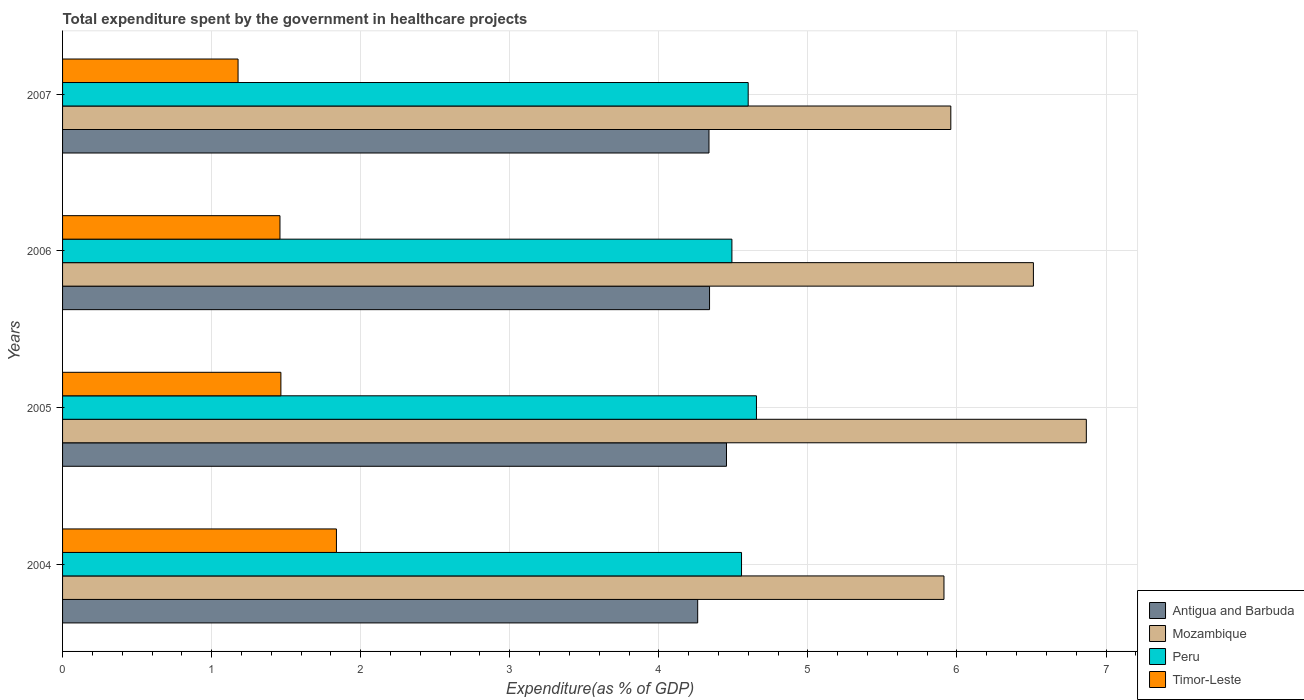How many groups of bars are there?
Offer a very short reply. 4. Are the number of bars on each tick of the Y-axis equal?
Your response must be concise. Yes. What is the label of the 4th group of bars from the top?
Keep it short and to the point. 2004. In how many cases, is the number of bars for a given year not equal to the number of legend labels?
Your answer should be very brief. 0. What is the total expenditure spent by the government in healthcare projects in Antigua and Barbuda in 2007?
Your answer should be very brief. 4.34. Across all years, what is the maximum total expenditure spent by the government in healthcare projects in Peru?
Your answer should be very brief. 4.65. Across all years, what is the minimum total expenditure spent by the government in healthcare projects in Timor-Leste?
Make the answer very short. 1.18. In which year was the total expenditure spent by the government in healthcare projects in Antigua and Barbuda maximum?
Your answer should be very brief. 2005. In which year was the total expenditure spent by the government in healthcare projects in Mozambique minimum?
Offer a terse response. 2004. What is the total total expenditure spent by the government in healthcare projects in Mozambique in the graph?
Your answer should be compact. 25.25. What is the difference between the total expenditure spent by the government in healthcare projects in Mozambique in 2004 and that in 2006?
Ensure brevity in your answer.  -0.6. What is the difference between the total expenditure spent by the government in healthcare projects in Antigua and Barbuda in 2006 and the total expenditure spent by the government in healthcare projects in Mozambique in 2005?
Give a very brief answer. -2.53. What is the average total expenditure spent by the government in healthcare projects in Peru per year?
Ensure brevity in your answer.  4.57. In the year 2004, what is the difference between the total expenditure spent by the government in healthcare projects in Timor-Leste and total expenditure spent by the government in healthcare projects in Peru?
Give a very brief answer. -2.72. What is the ratio of the total expenditure spent by the government in healthcare projects in Mozambique in 2006 to that in 2007?
Ensure brevity in your answer.  1.09. What is the difference between the highest and the second highest total expenditure spent by the government in healthcare projects in Mozambique?
Give a very brief answer. 0.36. What is the difference between the highest and the lowest total expenditure spent by the government in healthcare projects in Timor-Leste?
Your answer should be very brief. 0.66. Is it the case that in every year, the sum of the total expenditure spent by the government in healthcare projects in Peru and total expenditure spent by the government in healthcare projects in Mozambique is greater than the sum of total expenditure spent by the government in healthcare projects in Antigua and Barbuda and total expenditure spent by the government in healthcare projects in Timor-Leste?
Keep it short and to the point. Yes. What does the 3rd bar from the top in 2007 represents?
Keep it short and to the point. Mozambique. What does the 2nd bar from the bottom in 2006 represents?
Provide a succinct answer. Mozambique. Is it the case that in every year, the sum of the total expenditure spent by the government in healthcare projects in Peru and total expenditure spent by the government in healthcare projects in Antigua and Barbuda is greater than the total expenditure spent by the government in healthcare projects in Timor-Leste?
Provide a short and direct response. Yes. Are the values on the major ticks of X-axis written in scientific E-notation?
Give a very brief answer. No. Does the graph contain any zero values?
Offer a terse response. No. How many legend labels are there?
Offer a terse response. 4. What is the title of the graph?
Provide a succinct answer. Total expenditure spent by the government in healthcare projects. Does "Korea (Democratic)" appear as one of the legend labels in the graph?
Keep it short and to the point. No. What is the label or title of the X-axis?
Make the answer very short. Expenditure(as % of GDP). What is the label or title of the Y-axis?
Provide a succinct answer. Years. What is the Expenditure(as % of GDP) of Antigua and Barbuda in 2004?
Your response must be concise. 4.26. What is the Expenditure(as % of GDP) in Mozambique in 2004?
Provide a short and direct response. 5.91. What is the Expenditure(as % of GDP) of Peru in 2004?
Your answer should be very brief. 4.55. What is the Expenditure(as % of GDP) of Timor-Leste in 2004?
Offer a terse response. 1.84. What is the Expenditure(as % of GDP) in Antigua and Barbuda in 2005?
Provide a short and direct response. 4.45. What is the Expenditure(as % of GDP) of Mozambique in 2005?
Your answer should be very brief. 6.87. What is the Expenditure(as % of GDP) in Peru in 2005?
Your answer should be compact. 4.65. What is the Expenditure(as % of GDP) of Timor-Leste in 2005?
Your answer should be compact. 1.46. What is the Expenditure(as % of GDP) in Antigua and Barbuda in 2006?
Give a very brief answer. 4.34. What is the Expenditure(as % of GDP) in Mozambique in 2006?
Give a very brief answer. 6.51. What is the Expenditure(as % of GDP) of Peru in 2006?
Provide a succinct answer. 4.49. What is the Expenditure(as % of GDP) of Timor-Leste in 2006?
Your answer should be compact. 1.46. What is the Expenditure(as % of GDP) in Antigua and Barbuda in 2007?
Offer a terse response. 4.34. What is the Expenditure(as % of GDP) in Mozambique in 2007?
Ensure brevity in your answer.  5.96. What is the Expenditure(as % of GDP) in Peru in 2007?
Keep it short and to the point. 4.6. What is the Expenditure(as % of GDP) in Timor-Leste in 2007?
Make the answer very short. 1.18. Across all years, what is the maximum Expenditure(as % of GDP) in Antigua and Barbuda?
Provide a succinct answer. 4.45. Across all years, what is the maximum Expenditure(as % of GDP) in Mozambique?
Your response must be concise. 6.87. Across all years, what is the maximum Expenditure(as % of GDP) of Peru?
Keep it short and to the point. 4.65. Across all years, what is the maximum Expenditure(as % of GDP) in Timor-Leste?
Provide a short and direct response. 1.84. Across all years, what is the minimum Expenditure(as % of GDP) of Antigua and Barbuda?
Your response must be concise. 4.26. Across all years, what is the minimum Expenditure(as % of GDP) in Mozambique?
Your answer should be compact. 5.91. Across all years, what is the minimum Expenditure(as % of GDP) of Peru?
Provide a succinct answer. 4.49. Across all years, what is the minimum Expenditure(as % of GDP) in Timor-Leste?
Offer a very short reply. 1.18. What is the total Expenditure(as % of GDP) of Antigua and Barbuda in the graph?
Make the answer very short. 17.39. What is the total Expenditure(as % of GDP) of Mozambique in the graph?
Provide a succinct answer. 25.25. What is the total Expenditure(as % of GDP) of Peru in the graph?
Your response must be concise. 18.3. What is the total Expenditure(as % of GDP) of Timor-Leste in the graph?
Offer a very short reply. 5.94. What is the difference between the Expenditure(as % of GDP) of Antigua and Barbuda in 2004 and that in 2005?
Offer a terse response. -0.19. What is the difference between the Expenditure(as % of GDP) in Mozambique in 2004 and that in 2005?
Your answer should be very brief. -0.96. What is the difference between the Expenditure(as % of GDP) of Peru in 2004 and that in 2005?
Provide a short and direct response. -0.1. What is the difference between the Expenditure(as % of GDP) of Timor-Leste in 2004 and that in 2005?
Provide a short and direct response. 0.37. What is the difference between the Expenditure(as % of GDP) of Antigua and Barbuda in 2004 and that in 2006?
Make the answer very short. -0.08. What is the difference between the Expenditure(as % of GDP) of Mozambique in 2004 and that in 2006?
Offer a very short reply. -0.6. What is the difference between the Expenditure(as % of GDP) of Peru in 2004 and that in 2006?
Your answer should be very brief. 0.06. What is the difference between the Expenditure(as % of GDP) in Timor-Leste in 2004 and that in 2006?
Give a very brief answer. 0.38. What is the difference between the Expenditure(as % of GDP) in Antigua and Barbuda in 2004 and that in 2007?
Make the answer very short. -0.08. What is the difference between the Expenditure(as % of GDP) in Mozambique in 2004 and that in 2007?
Your response must be concise. -0.05. What is the difference between the Expenditure(as % of GDP) in Peru in 2004 and that in 2007?
Keep it short and to the point. -0.04. What is the difference between the Expenditure(as % of GDP) of Timor-Leste in 2004 and that in 2007?
Ensure brevity in your answer.  0.66. What is the difference between the Expenditure(as % of GDP) in Antigua and Barbuda in 2005 and that in 2006?
Provide a short and direct response. 0.11. What is the difference between the Expenditure(as % of GDP) of Mozambique in 2005 and that in 2006?
Keep it short and to the point. 0.35. What is the difference between the Expenditure(as % of GDP) in Peru in 2005 and that in 2006?
Offer a very short reply. 0.16. What is the difference between the Expenditure(as % of GDP) in Timor-Leste in 2005 and that in 2006?
Your answer should be compact. 0.01. What is the difference between the Expenditure(as % of GDP) of Antigua and Barbuda in 2005 and that in 2007?
Your answer should be very brief. 0.12. What is the difference between the Expenditure(as % of GDP) in Peru in 2005 and that in 2007?
Make the answer very short. 0.06. What is the difference between the Expenditure(as % of GDP) of Timor-Leste in 2005 and that in 2007?
Your answer should be very brief. 0.29. What is the difference between the Expenditure(as % of GDP) of Antigua and Barbuda in 2006 and that in 2007?
Your response must be concise. 0. What is the difference between the Expenditure(as % of GDP) of Mozambique in 2006 and that in 2007?
Offer a very short reply. 0.55. What is the difference between the Expenditure(as % of GDP) in Peru in 2006 and that in 2007?
Make the answer very short. -0.11. What is the difference between the Expenditure(as % of GDP) in Timor-Leste in 2006 and that in 2007?
Offer a terse response. 0.28. What is the difference between the Expenditure(as % of GDP) of Antigua and Barbuda in 2004 and the Expenditure(as % of GDP) of Mozambique in 2005?
Provide a short and direct response. -2.61. What is the difference between the Expenditure(as % of GDP) of Antigua and Barbuda in 2004 and the Expenditure(as % of GDP) of Peru in 2005?
Provide a short and direct response. -0.39. What is the difference between the Expenditure(as % of GDP) of Antigua and Barbuda in 2004 and the Expenditure(as % of GDP) of Timor-Leste in 2005?
Your response must be concise. 2.8. What is the difference between the Expenditure(as % of GDP) in Mozambique in 2004 and the Expenditure(as % of GDP) in Peru in 2005?
Ensure brevity in your answer.  1.26. What is the difference between the Expenditure(as % of GDP) of Mozambique in 2004 and the Expenditure(as % of GDP) of Timor-Leste in 2005?
Give a very brief answer. 4.45. What is the difference between the Expenditure(as % of GDP) in Peru in 2004 and the Expenditure(as % of GDP) in Timor-Leste in 2005?
Offer a terse response. 3.09. What is the difference between the Expenditure(as % of GDP) in Antigua and Barbuda in 2004 and the Expenditure(as % of GDP) in Mozambique in 2006?
Keep it short and to the point. -2.25. What is the difference between the Expenditure(as % of GDP) in Antigua and Barbuda in 2004 and the Expenditure(as % of GDP) in Peru in 2006?
Your answer should be compact. -0.23. What is the difference between the Expenditure(as % of GDP) of Antigua and Barbuda in 2004 and the Expenditure(as % of GDP) of Timor-Leste in 2006?
Your response must be concise. 2.8. What is the difference between the Expenditure(as % of GDP) in Mozambique in 2004 and the Expenditure(as % of GDP) in Peru in 2006?
Give a very brief answer. 1.42. What is the difference between the Expenditure(as % of GDP) of Mozambique in 2004 and the Expenditure(as % of GDP) of Timor-Leste in 2006?
Provide a short and direct response. 4.45. What is the difference between the Expenditure(as % of GDP) in Peru in 2004 and the Expenditure(as % of GDP) in Timor-Leste in 2006?
Keep it short and to the point. 3.1. What is the difference between the Expenditure(as % of GDP) of Antigua and Barbuda in 2004 and the Expenditure(as % of GDP) of Mozambique in 2007?
Provide a short and direct response. -1.7. What is the difference between the Expenditure(as % of GDP) of Antigua and Barbuda in 2004 and the Expenditure(as % of GDP) of Peru in 2007?
Keep it short and to the point. -0.34. What is the difference between the Expenditure(as % of GDP) in Antigua and Barbuda in 2004 and the Expenditure(as % of GDP) in Timor-Leste in 2007?
Make the answer very short. 3.08. What is the difference between the Expenditure(as % of GDP) of Mozambique in 2004 and the Expenditure(as % of GDP) of Peru in 2007?
Offer a terse response. 1.31. What is the difference between the Expenditure(as % of GDP) of Mozambique in 2004 and the Expenditure(as % of GDP) of Timor-Leste in 2007?
Provide a succinct answer. 4.74. What is the difference between the Expenditure(as % of GDP) in Peru in 2004 and the Expenditure(as % of GDP) in Timor-Leste in 2007?
Provide a succinct answer. 3.38. What is the difference between the Expenditure(as % of GDP) in Antigua and Barbuda in 2005 and the Expenditure(as % of GDP) in Mozambique in 2006?
Your answer should be very brief. -2.06. What is the difference between the Expenditure(as % of GDP) in Antigua and Barbuda in 2005 and the Expenditure(as % of GDP) in Peru in 2006?
Ensure brevity in your answer.  -0.04. What is the difference between the Expenditure(as % of GDP) of Antigua and Barbuda in 2005 and the Expenditure(as % of GDP) of Timor-Leste in 2006?
Ensure brevity in your answer.  3. What is the difference between the Expenditure(as % of GDP) in Mozambique in 2005 and the Expenditure(as % of GDP) in Peru in 2006?
Your answer should be very brief. 2.38. What is the difference between the Expenditure(as % of GDP) in Mozambique in 2005 and the Expenditure(as % of GDP) in Timor-Leste in 2006?
Provide a short and direct response. 5.41. What is the difference between the Expenditure(as % of GDP) of Peru in 2005 and the Expenditure(as % of GDP) of Timor-Leste in 2006?
Ensure brevity in your answer.  3.2. What is the difference between the Expenditure(as % of GDP) of Antigua and Barbuda in 2005 and the Expenditure(as % of GDP) of Mozambique in 2007?
Your response must be concise. -1.5. What is the difference between the Expenditure(as % of GDP) of Antigua and Barbuda in 2005 and the Expenditure(as % of GDP) of Peru in 2007?
Provide a succinct answer. -0.15. What is the difference between the Expenditure(as % of GDP) in Antigua and Barbuda in 2005 and the Expenditure(as % of GDP) in Timor-Leste in 2007?
Give a very brief answer. 3.28. What is the difference between the Expenditure(as % of GDP) in Mozambique in 2005 and the Expenditure(as % of GDP) in Peru in 2007?
Make the answer very short. 2.27. What is the difference between the Expenditure(as % of GDP) in Mozambique in 2005 and the Expenditure(as % of GDP) in Timor-Leste in 2007?
Offer a very short reply. 5.69. What is the difference between the Expenditure(as % of GDP) in Peru in 2005 and the Expenditure(as % of GDP) in Timor-Leste in 2007?
Your answer should be compact. 3.48. What is the difference between the Expenditure(as % of GDP) of Antigua and Barbuda in 2006 and the Expenditure(as % of GDP) of Mozambique in 2007?
Your answer should be very brief. -1.62. What is the difference between the Expenditure(as % of GDP) in Antigua and Barbuda in 2006 and the Expenditure(as % of GDP) in Peru in 2007?
Keep it short and to the point. -0.26. What is the difference between the Expenditure(as % of GDP) in Antigua and Barbuda in 2006 and the Expenditure(as % of GDP) in Timor-Leste in 2007?
Provide a succinct answer. 3.16. What is the difference between the Expenditure(as % of GDP) in Mozambique in 2006 and the Expenditure(as % of GDP) in Peru in 2007?
Give a very brief answer. 1.91. What is the difference between the Expenditure(as % of GDP) in Mozambique in 2006 and the Expenditure(as % of GDP) in Timor-Leste in 2007?
Provide a short and direct response. 5.34. What is the difference between the Expenditure(as % of GDP) in Peru in 2006 and the Expenditure(as % of GDP) in Timor-Leste in 2007?
Your answer should be compact. 3.31. What is the average Expenditure(as % of GDP) of Antigua and Barbuda per year?
Your answer should be very brief. 4.35. What is the average Expenditure(as % of GDP) in Mozambique per year?
Offer a very short reply. 6.31. What is the average Expenditure(as % of GDP) in Peru per year?
Your answer should be very brief. 4.57. What is the average Expenditure(as % of GDP) of Timor-Leste per year?
Provide a short and direct response. 1.48. In the year 2004, what is the difference between the Expenditure(as % of GDP) in Antigua and Barbuda and Expenditure(as % of GDP) in Mozambique?
Offer a terse response. -1.65. In the year 2004, what is the difference between the Expenditure(as % of GDP) in Antigua and Barbuda and Expenditure(as % of GDP) in Peru?
Provide a short and direct response. -0.29. In the year 2004, what is the difference between the Expenditure(as % of GDP) in Antigua and Barbuda and Expenditure(as % of GDP) in Timor-Leste?
Your answer should be very brief. 2.42. In the year 2004, what is the difference between the Expenditure(as % of GDP) of Mozambique and Expenditure(as % of GDP) of Peru?
Ensure brevity in your answer.  1.36. In the year 2004, what is the difference between the Expenditure(as % of GDP) in Mozambique and Expenditure(as % of GDP) in Timor-Leste?
Your answer should be very brief. 4.08. In the year 2004, what is the difference between the Expenditure(as % of GDP) of Peru and Expenditure(as % of GDP) of Timor-Leste?
Ensure brevity in your answer.  2.72. In the year 2005, what is the difference between the Expenditure(as % of GDP) in Antigua and Barbuda and Expenditure(as % of GDP) in Mozambique?
Make the answer very short. -2.41. In the year 2005, what is the difference between the Expenditure(as % of GDP) in Antigua and Barbuda and Expenditure(as % of GDP) in Peru?
Provide a short and direct response. -0.2. In the year 2005, what is the difference between the Expenditure(as % of GDP) of Antigua and Barbuda and Expenditure(as % of GDP) of Timor-Leste?
Offer a very short reply. 2.99. In the year 2005, what is the difference between the Expenditure(as % of GDP) in Mozambique and Expenditure(as % of GDP) in Peru?
Your answer should be compact. 2.21. In the year 2005, what is the difference between the Expenditure(as % of GDP) in Mozambique and Expenditure(as % of GDP) in Timor-Leste?
Make the answer very short. 5.4. In the year 2005, what is the difference between the Expenditure(as % of GDP) of Peru and Expenditure(as % of GDP) of Timor-Leste?
Ensure brevity in your answer.  3.19. In the year 2006, what is the difference between the Expenditure(as % of GDP) of Antigua and Barbuda and Expenditure(as % of GDP) of Mozambique?
Give a very brief answer. -2.17. In the year 2006, what is the difference between the Expenditure(as % of GDP) of Antigua and Barbuda and Expenditure(as % of GDP) of Peru?
Offer a very short reply. -0.15. In the year 2006, what is the difference between the Expenditure(as % of GDP) of Antigua and Barbuda and Expenditure(as % of GDP) of Timor-Leste?
Offer a very short reply. 2.88. In the year 2006, what is the difference between the Expenditure(as % of GDP) in Mozambique and Expenditure(as % of GDP) in Peru?
Ensure brevity in your answer.  2.02. In the year 2006, what is the difference between the Expenditure(as % of GDP) of Mozambique and Expenditure(as % of GDP) of Timor-Leste?
Keep it short and to the point. 5.05. In the year 2006, what is the difference between the Expenditure(as % of GDP) of Peru and Expenditure(as % of GDP) of Timor-Leste?
Ensure brevity in your answer.  3.03. In the year 2007, what is the difference between the Expenditure(as % of GDP) of Antigua and Barbuda and Expenditure(as % of GDP) of Mozambique?
Give a very brief answer. -1.62. In the year 2007, what is the difference between the Expenditure(as % of GDP) in Antigua and Barbuda and Expenditure(as % of GDP) in Peru?
Offer a terse response. -0.26. In the year 2007, what is the difference between the Expenditure(as % of GDP) in Antigua and Barbuda and Expenditure(as % of GDP) in Timor-Leste?
Offer a very short reply. 3.16. In the year 2007, what is the difference between the Expenditure(as % of GDP) in Mozambique and Expenditure(as % of GDP) in Peru?
Offer a terse response. 1.36. In the year 2007, what is the difference between the Expenditure(as % of GDP) in Mozambique and Expenditure(as % of GDP) in Timor-Leste?
Offer a very short reply. 4.78. In the year 2007, what is the difference between the Expenditure(as % of GDP) in Peru and Expenditure(as % of GDP) in Timor-Leste?
Give a very brief answer. 3.42. What is the ratio of the Expenditure(as % of GDP) of Antigua and Barbuda in 2004 to that in 2005?
Ensure brevity in your answer.  0.96. What is the ratio of the Expenditure(as % of GDP) of Mozambique in 2004 to that in 2005?
Your answer should be very brief. 0.86. What is the ratio of the Expenditure(as % of GDP) of Peru in 2004 to that in 2005?
Provide a succinct answer. 0.98. What is the ratio of the Expenditure(as % of GDP) of Timor-Leste in 2004 to that in 2005?
Your answer should be compact. 1.25. What is the ratio of the Expenditure(as % of GDP) of Antigua and Barbuda in 2004 to that in 2006?
Give a very brief answer. 0.98. What is the ratio of the Expenditure(as % of GDP) in Mozambique in 2004 to that in 2006?
Your answer should be compact. 0.91. What is the ratio of the Expenditure(as % of GDP) of Peru in 2004 to that in 2006?
Your response must be concise. 1.01. What is the ratio of the Expenditure(as % of GDP) in Timor-Leste in 2004 to that in 2006?
Make the answer very short. 1.26. What is the ratio of the Expenditure(as % of GDP) of Antigua and Barbuda in 2004 to that in 2007?
Keep it short and to the point. 0.98. What is the ratio of the Expenditure(as % of GDP) of Mozambique in 2004 to that in 2007?
Your answer should be compact. 0.99. What is the ratio of the Expenditure(as % of GDP) of Peru in 2004 to that in 2007?
Your answer should be very brief. 0.99. What is the ratio of the Expenditure(as % of GDP) of Timor-Leste in 2004 to that in 2007?
Your answer should be very brief. 1.56. What is the ratio of the Expenditure(as % of GDP) in Antigua and Barbuda in 2005 to that in 2006?
Provide a short and direct response. 1.03. What is the ratio of the Expenditure(as % of GDP) in Mozambique in 2005 to that in 2006?
Offer a terse response. 1.05. What is the ratio of the Expenditure(as % of GDP) in Peru in 2005 to that in 2006?
Your response must be concise. 1.04. What is the ratio of the Expenditure(as % of GDP) of Timor-Leste in 2005 to that in 2006?
Your response must be concise. 1. What is the ratio of the Expenditure(as % of GDP) of Antigua and Barbuda in 2005 to that in 2007?
Ensure brevity in your answer.  1.03. What is the ratio of the Expenditure(as % of GDP) in Mozambique in 2005 to that in 2007?
Offer a terse response. 1.15. What is the ratio of the Expenditure(as % of GDP) of Peru in 2005 to that in 2007?
Keep it short and to the point. 1.01. What is the ratio of the Expenditure(as % of GDP) of Timor-Leste in 2005 to that in 2007?
Provide a succinct answer. 1.24. What is the ratio of the Expenditure(as % of GDP) in Mozambique in 2006 to that in 2007?
Provide a succinct answer. 1.09. What is the ratio of the Expenditure(as % of GDP) of Peru in 2006 to that in 2007?
Give a very brief answer. 0.98. What is the ratio of the Expenditure(as % of GDP) of Timor-Leste in 2006 to that in 2007?
Your answer should be compact. 1.24. What is the difference between the highest and the second highest Expenditure(as % of GDP) in Antigua and Barbuda?
Your answer should be compact. 0.11. What is the difference between the highest and the second highest Expenditure(as % of GDP) of Mozambique?
Provide a succinct answer. 0.35. What is the difference between the highest and the second highest Expenditure(as % of GDP) of Peru?
Keep it short and to the point. 0.06. What is the difference between the highest and the second highest Expenditure(as % of GDP) in Timor-Leste?
Your answer should be very brief. 0.37. What is the difference between the highest and the lowest Expenditure(as % of GDP) in Antigua and Barbuda?
Your answer should be very brief. 0.19. What is the difference between the highest and the lowest Expenditure(as % of GDP) in Mozambique?
Give a very brief answer. 0.96. What is the difference between the highest and the lowest Expenditure(as % of GDP) of Peru?
Ensure brevity in your answer.  0.16. What is the difference between the highest and the lowest Expenditure(as % of GDP) in Timor-Leste?
Provide a succinct answer. 0.66. 